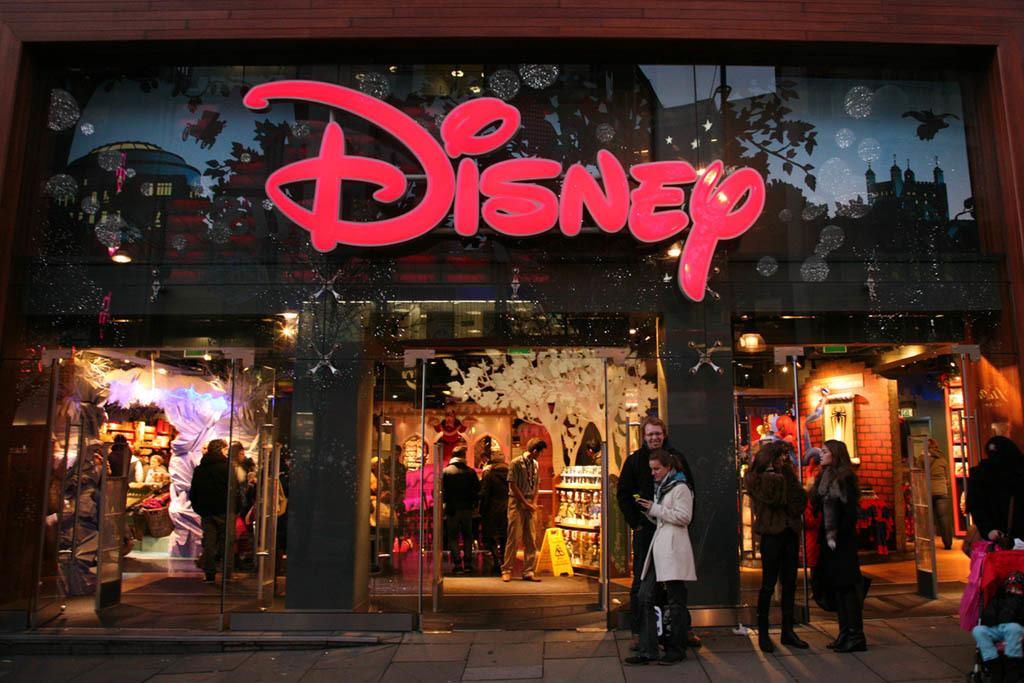What is the main subject of the image? The main subject of the image is a crowd. Where is the crowd located in the image? The crowd is on the road and in a shop. What can be seen in the background of the image? In the background of the image, there is a building, a board, lights, some objects, and a wall. Can you describe the lighting conditions in the image? The image may have been taken during the night, as there are lights visible in the background. What type of memory is being used by the chicken in the image? There is no chicken or memory present in the image. 